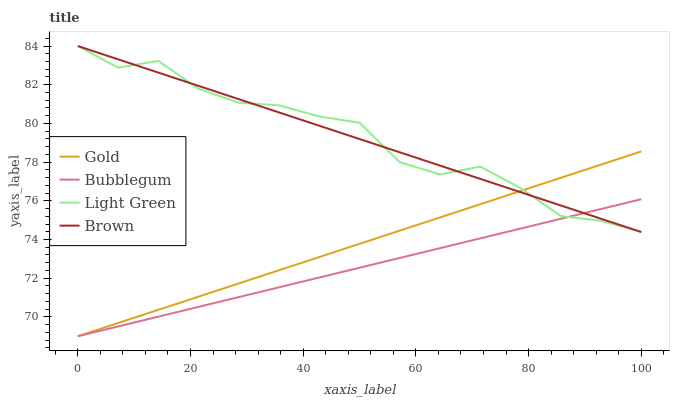Does Bubblegum have the minimum area under the curve?
Answer yes or no. Yes. Does Light Green have the maximum area under the curve?
Answer yes or no. Yes. Does Light Green have the minimum area under the curve?
Answer yes or no. No. Does Bubblegum have the maximum area under the curve?
Answer yes or no. No. Is Bubblegum the smoothest?
Answer yes or no. Yes. Is Light Green the roughest?
Answer yes or no. Yes. Is Light Green the smoothest?
Answer yes or no. No. Is Bubblegum the roughest?
Answer yes or no. No. Does Bubblegum have the lowest value?
Answer yes or no. Yes. Does Light Green have the lowest value?
Answer yes or no. No. Does Light Green have the highest value?
Answer yes or no. Yes. Does Bubblegum have the highest value?
Answer yes or no. No. Does Gold intersect Brown?
Answer yes or no. Yes. Is Gold less than Brown?
Answer yes or no. No. Is Gold greater than Brown?
Answer yes or no. No. 